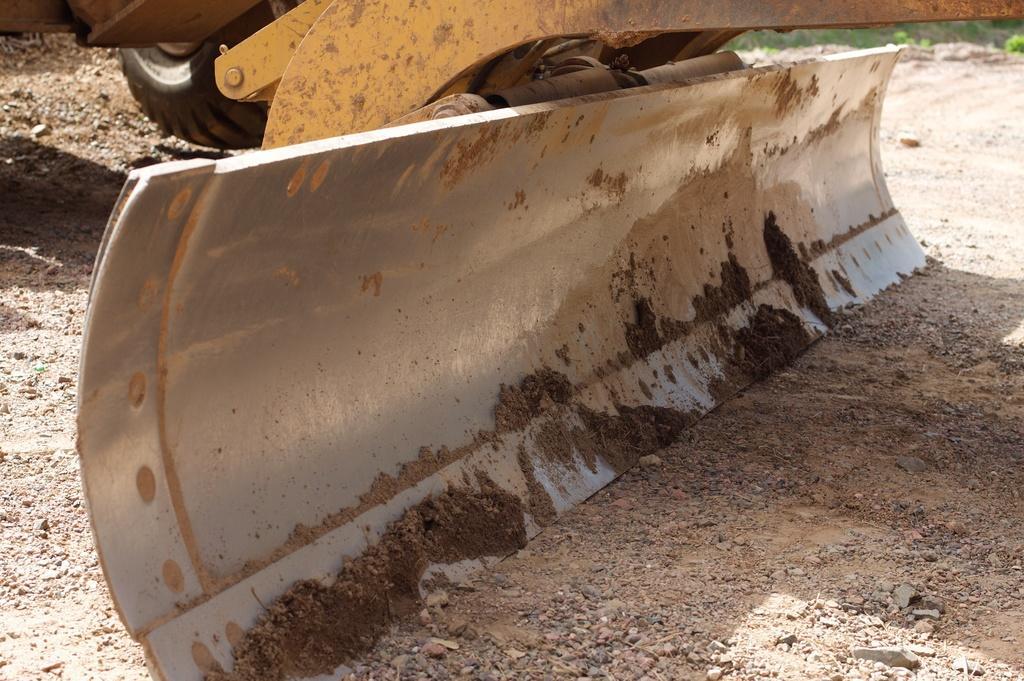Describe this image in one or two sentences. In this image I can see the bulldozer which is in yellow color. It is on the ground. To the side I can see the grass. 